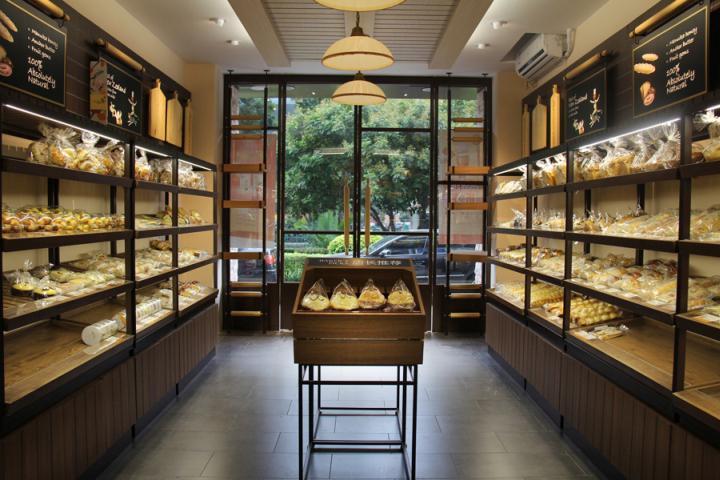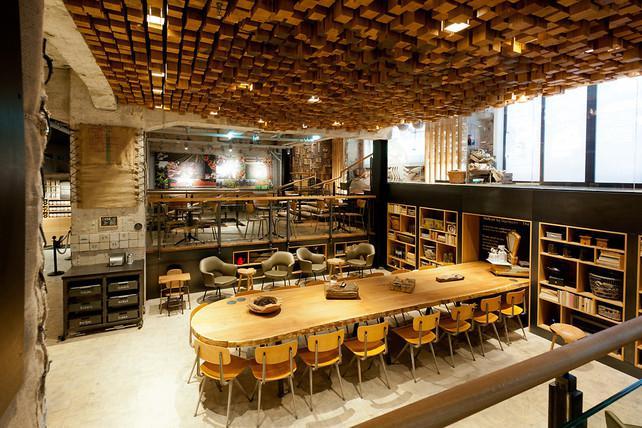The first image is the image on the left, the second image is the image on the right. Examine the images to the left and right. Is the description "The bakery in one image has white tile walls and uses black paddles for signs." accurate? Answer yes or no. No. 